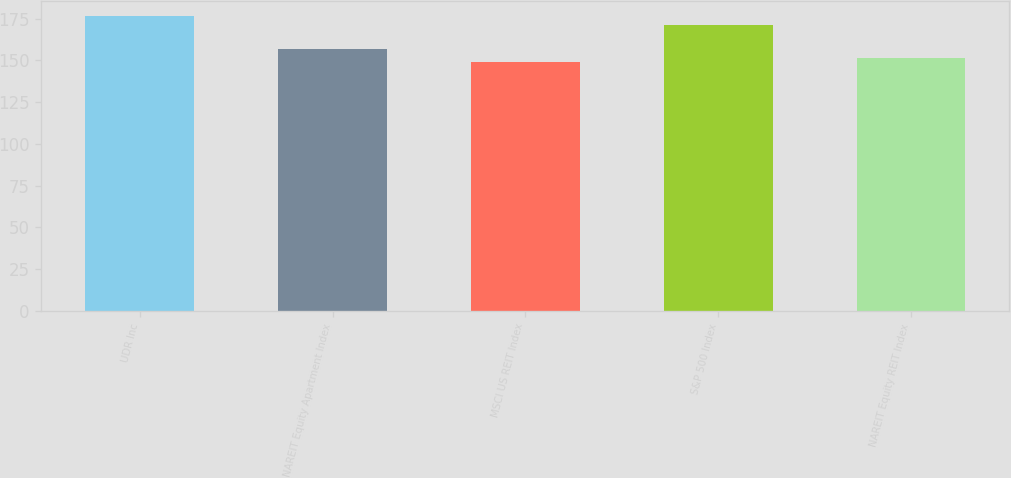Convert chart. <chart><loc_0><loc_0><loc_500><loc_500><bar_chart><fcel>UDR Inc<fcel>NAREIT Equity Apartment Index<fcel>MSCI US REIT Index<fcel>S&P 500 Index<fcel>NAREIT Equity REIT Index<nl><fcel>176.68<fcel>156.88<fcel>148.75<fcel>170.84<fcel>151.54<nl></chart> 